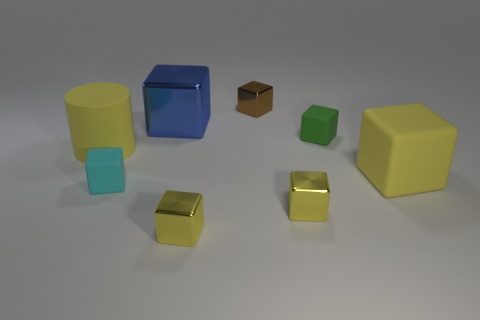What materials do the objects in the image appear to be made of? The objects in the image seem to vary in material. The big cylinder and the large cube have a shiny, rubber-like surface, indicative of a plastic or rubber material with a reflective property. The small brown cube looks like it could be made of wood, given its matte finish and grained texture. The yellow cube and the green cube have an almost velvety look, suggesting they might be made of a more porous, possibly foamy material. 